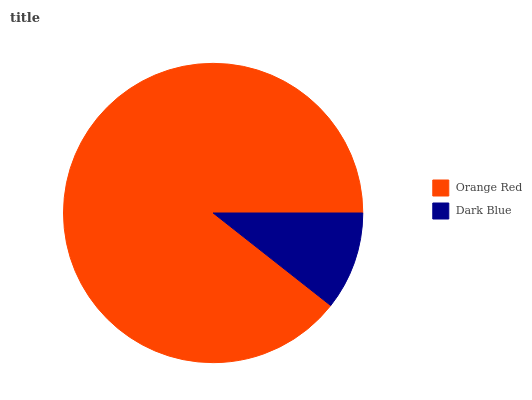Is Dark Blue the minimum?
Answer yes or no. Yes. Is Orange Red the maximum?
Answer yes or no. Yes. Is Dark Blue the maximum?
Answer yes or no. No. Is Orange Red greater than Dark Blue?
Answer yes or no. Yes. Is Dark Blue less than Orange Red?
Answer yes or no. Yes. Is Dark Blue greater than Orange Red?
Answer yes or no. No. Is Orange Red less than Dark Blue?
Answer yes or no. No. Is Orange Red the high median?
Answer yes or no. Yes. Is Dark Blue the low median?
Answer yes or no. Yes. Is Dark Blue the high median?
Answer yes or no. No. Is Orange Red the low median?
Answer yes or no. No. 